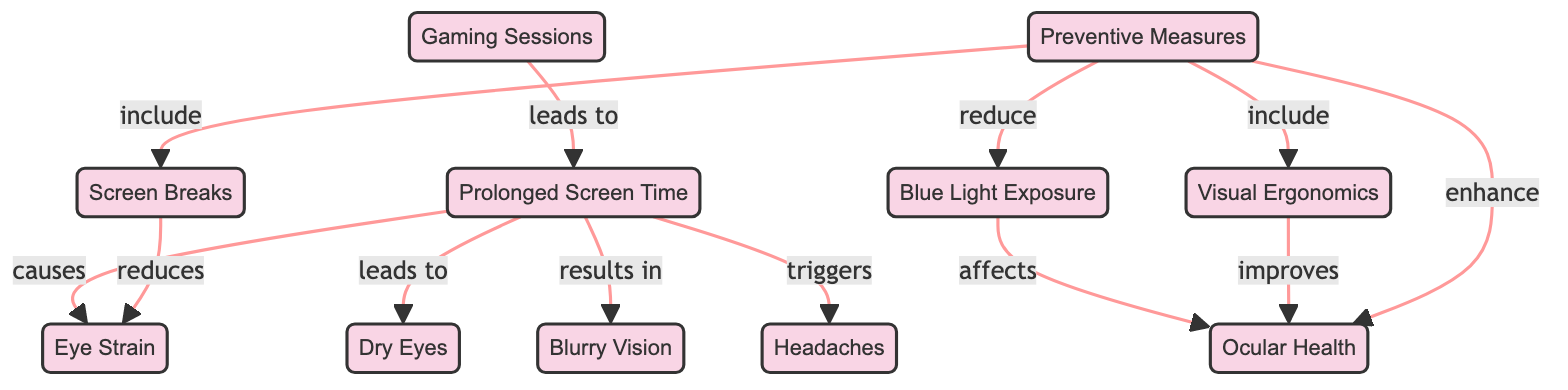What are the effects of prolonged screen time on ocular health? The diagram shows that prolonged screen time leads to eye strain, dry eyes, blurry vision, and headaches. Each of these conditions is directly connected to the node labeled "Prolonged Screen Time," illustrating the negative impact on ocular health.
Answer: Eye strain, dry eyes, blurry vision, headaches How does blue light exposure affect ocular health? The diagram indicates that blue light exposure directly affects ocular health, establishing a relationship between these two nodes. This shows that increased exposure can have a detrimental impact on visual well-being.
Answer: Affects ocular health Which preventive measure can reduce eye strain? According to the diagram, screen breaks are identified as a preventive measure that reduces eye strain. This relationship is directly indicated in the flow from "Screen Breaks" to "Eye Strain."
Answer: Screen breaks How many nodes are in this diagram? Counting each unique node listed in the diagram, such as "Prolonged Screen Time," "Eye Strain," "Dry Eyes," etc., totals to ten distinct nodes. Each represents a different aspect related to screen time and ocular health.
Answer: Ten What is the relationship between visual ergonomics and ocular health? The diagram shows a direct link where visual ergonomics improves ocular health. This suggests that applying ergonomic practices while using screens can lead to better eye health outcomes.
Answer: Improves ocular health How many preventive measures are mentioned in the diagram? The diagram outlines three preventive measures: screen breaks, visual ergonomics, and reducing blue light exposure. These are explicitly listed as methods to enhance ocular health.
Answer: Three What triggers headaches in this diagram? The diagram indicates that prolonged screen time triggers headaches. This is shown as a direct causative link from "Prolonged Screen Time" to "Headaches."
Answer: Prolonged screen time What is the primary node related to gaming sessions? In the diagram, "Gaming Sessions" is the primary node that leads to "Prolonged Screen Time." This highlights the connection between extended gaming and increased screen time, which influences ocular health.
Answer: Prolonged screen time Which condition is a result of prolonged screen time? The diagram states that blurry vision results from prolonged screen time. This shows that extended exposure can lead to visual impairment.
Answer: Blurry vision 